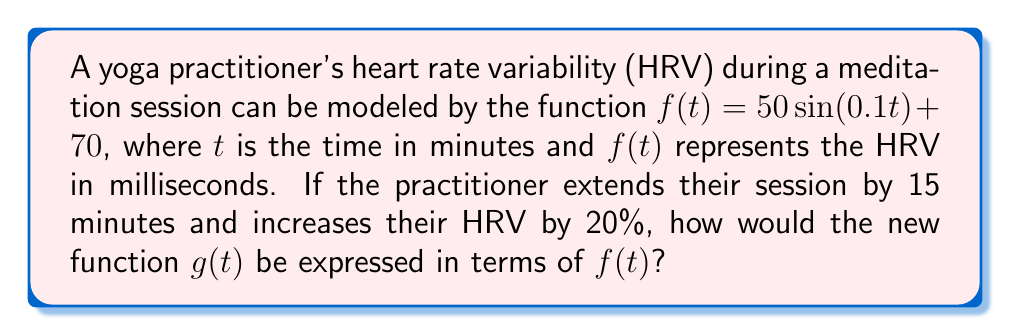Teach me how to tackle this problem. Let's approach this step-by-step:

1) First, we need to consider the time extension. Extending the session by 15 minutes means we need to compress the original function horizontally. This is achieved by multiplying the input by a factor. Let's call this factor $a$:

   $g(t) = f(at)$

   To extend by 15 minutes, we need: $a \cdot (t+15) = t$
   Solving this: $at + 15a = t$
   $15a = t - at = t(1-a)$
   $a = \frac{t}{t+15}$

2) Now, we need to account for the 20% increase in HRV. This is a vertical stretch by a factor of 1.2:

   $g(t) = 1.2f(at)$

3) Putting this all together:

   $g(t) = 1.2f(\frac{t}{t+15})$

This is the final transformation of the original function $f(t)$.
Answer: $g(t) = 1.2f(\frac{t}{t+15})$ 